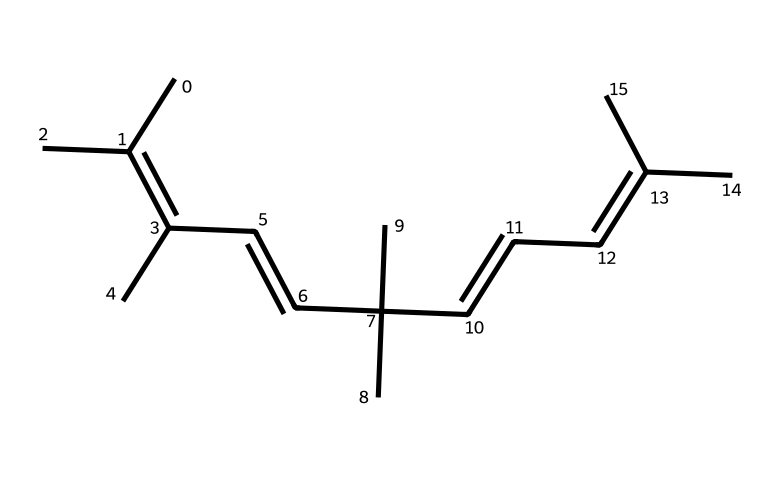What is the molecular formula of this compound? The molecular formula can be derived from the SMILES representation by counting the number of carbons and hydrogens. Counting the carbons in the structure, we see there are 20 carbon atoms. For hydrogens, considering the number of double bonds and the structure, we find there are 34 hydrogen atoms. Thus, the molecular formula is C20H34.
Answer: C20H34 How many double bonds are present in this compound? By analyzing the SMILES representation, we identify the locations of the double bonds indicated by the '=' symbol. There are four double bonds when following the structure sequentially. Therefore, the total number of double bonds is four.
Answer: 4 What type of stereoisomerism is exhibited in this compound? This compound exhibits geometric isomerism, specifically cis-trans isomerism, due to the presence of the double bonds and the different spatial arrangements of the substituents around these double bonds.
Answer: cis-trans isomerism Which carbon atoms can exhibit cis-trans isomerism? Identification of the double bonds reveals that the carbon atoms involved in the double bonds and their substituents dictate where cis-trans isomerism can occur. Specifically, the carbon-carbon double bonds at C2=C3 and C6=C7 are critical for this isomerism.
Answer: C2, C3, C6, C7 What effect does the presence of double bonds have on the fluidity of the synthetic rubber? The presence of double bonds introduces rigidity to the polymer structure, reducing the flexibility of chains due to steric hinderance and decreasing fluidity compared to saturated polymers. Hence, this leads to enhanced stability and durability in racing tires.
Answer: Reduced fluidity How does the arrangement of methyl groups affect the properties of the rubber? The positioning of the methyl groups influences the overall geometry and packing of the polymer chains. This affects properties like hardness, elasticity, and thermal stability, which are crucial for performance in racing tires.
Answer: Affects hardness and elasticity 